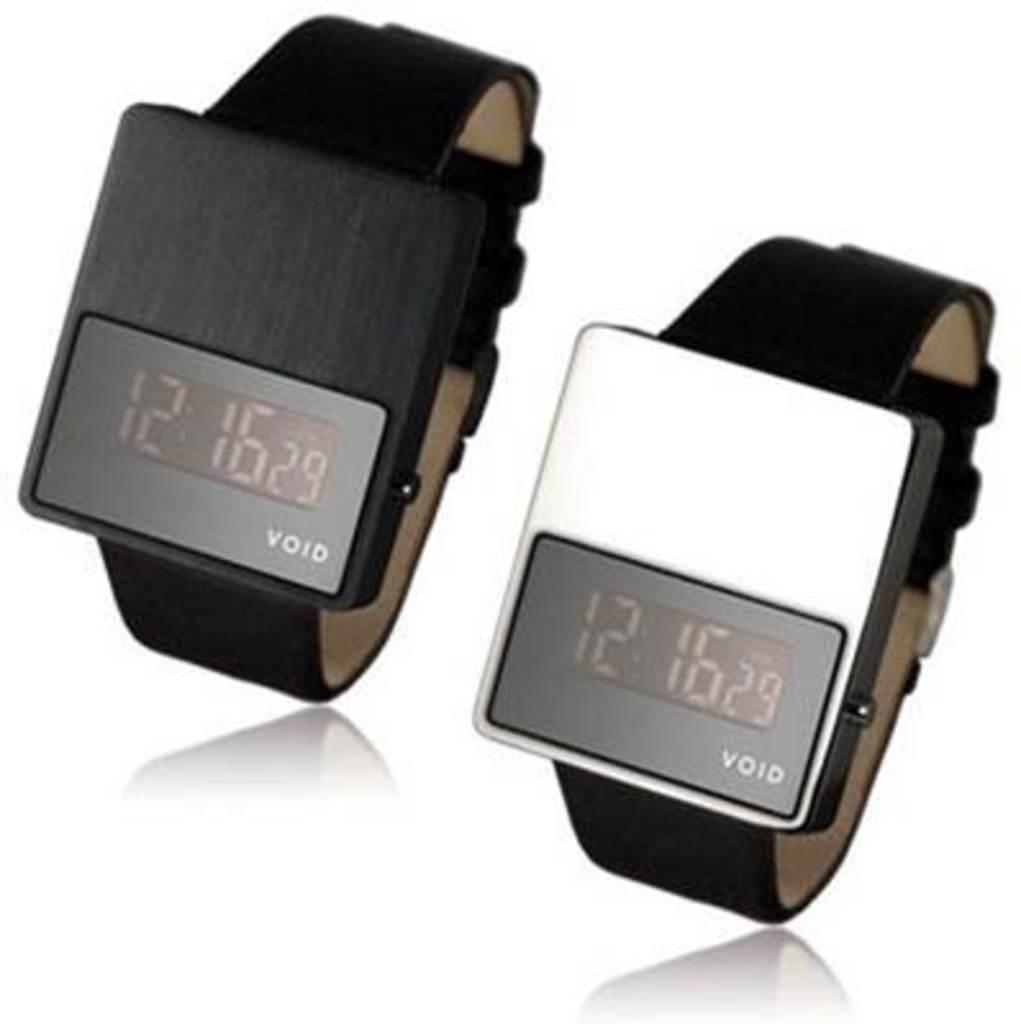<image>
Write a terse but informative summary of the picture. Two Void watches are next to each other and both read 12:16. 